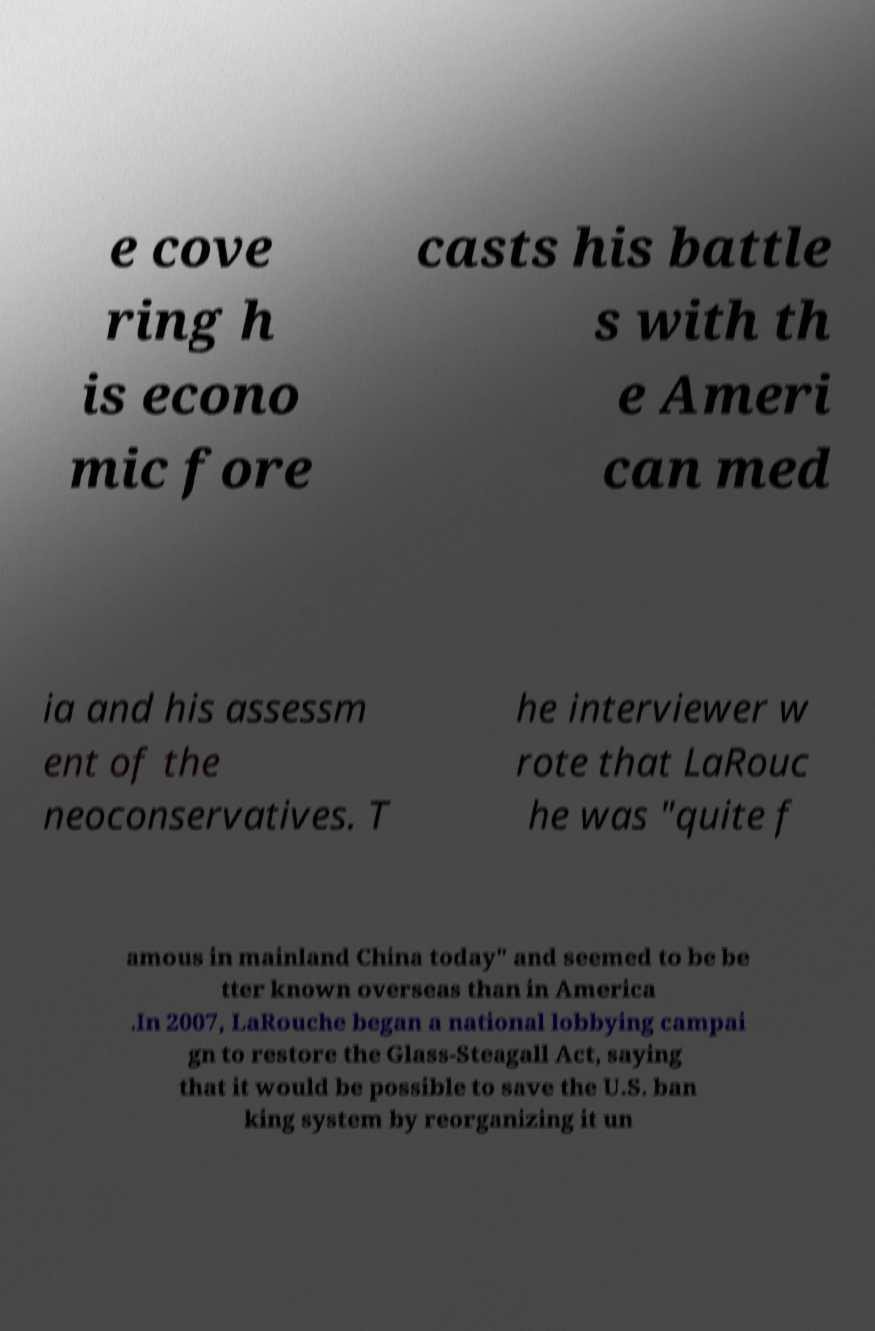Can you accurately transcribe the text from the provided image for me? e cove ring h is econo mic fore casts his battle s with th e Ameri can med ia and his assessm ent of the neoconservatives. T he interviewer w rote that LaRouc he was "quite f amous in mainland China today" and seemed to be be tter known overseas than in America .In 2007, LaRouche began a national lobbying campai gn to restore the Glass-Steagall Act, saying that it would be possible to save the U.S. ban king system by reorganizing it un 